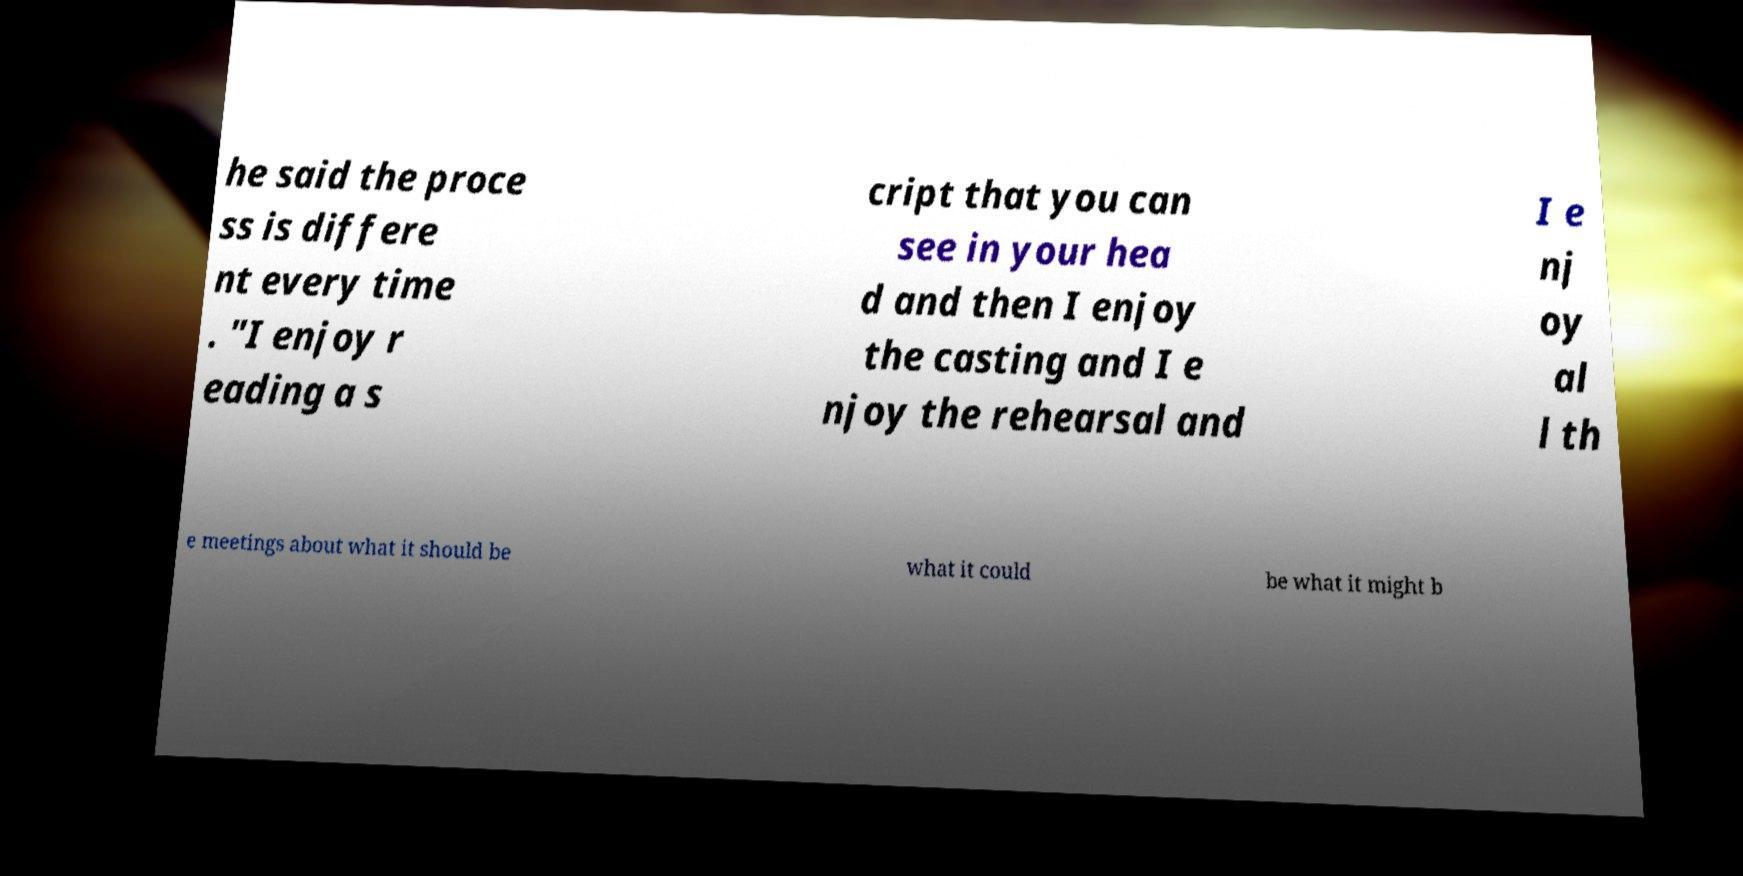Please identify and transcribe the text found in this image. he said the proce ss is differe nt every time . "I enjoy r eading a s cript that you can see in your hea d and then I enjoy the casting and I e njoy the rehearsal and I e nj oy al l th e meetings about what it should be what it could be what it might b 